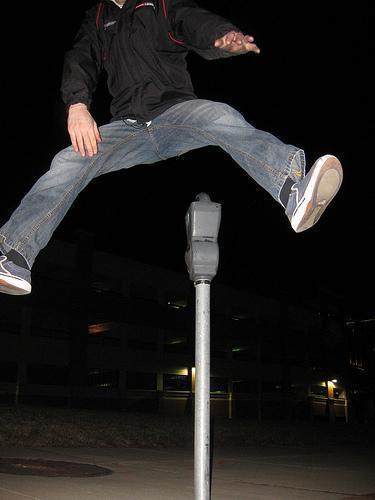How many people are shown?
Give a very brief answer. 1. 